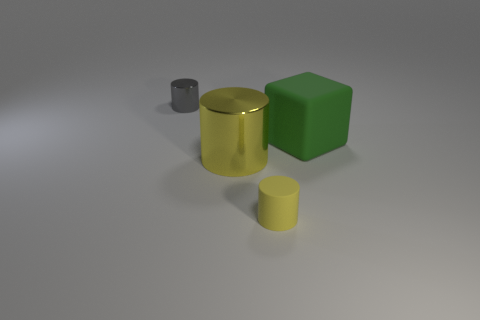Subtract all metallic cylinders. How many cylinders are left? 1 Add 2 small yellow things. How many objects exist? 6 Subtract 0 green spheres. How many objects are left? 4 Subtract all blocks. How many objects are left? 3 Subtract all cyan rubber cylinders. Subtract all large yellow metal objects. How many objects are left? 3 Add 1 gray metal things. How many gray metal things are left? 2 Add 3 tiny cyan metal blocks. How many tiny cyan metal blocks exist? 3 